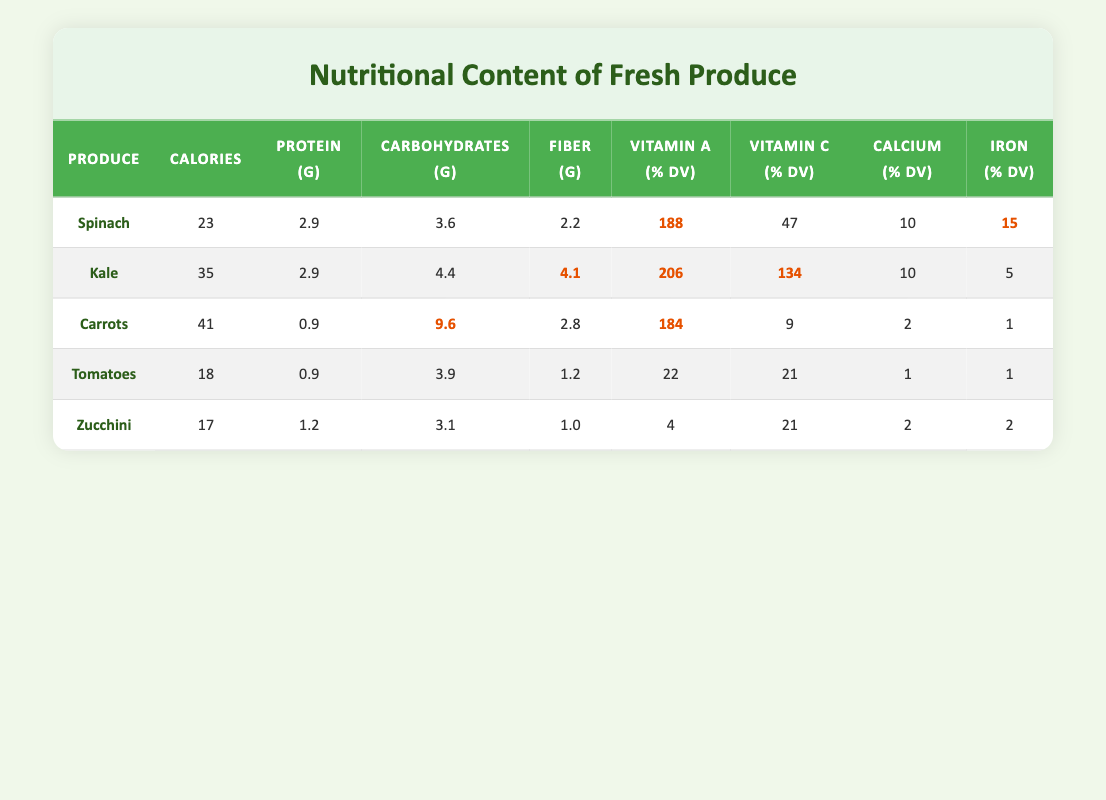What is the total protein content in spinach and kale combined? To find the total protein content, I will look at the protein values listed for spinach (2.9 g) and kale (2.9 g). Adding these together gives 2.9 + 2.9 = 5.8 g.
Answer: 5.8 g Which produce has the highest Vitamin C percentage? By examining the Vitamin C (% DV) column, kale has the highest value at 134%.
Answer: Kale Is the calcium content in carrots greater than that in tomatoes? Looking at the calcium (% DV) values, carrots have a value of 2%, while tomatoes have a value of 1%. Since 2% is greater than 1%, the statement is true.
Answer: Yes What is the average calorie content of all the produce listed? To calculate the average, I will sum the calories: 23 (spinach) + 35 (kale) + 41 (carrots) + 18 (tomatoes) + 17 (zucchini) = 134. Then, divide by the number of produce (5): 134 ÷ 5 = 26.8.
Answer: 26.8 Do any of these produce items provide 100% or more of the daily value of Vitamin A? Checking the Vitamin A (% DV) values, spinach (188%), kale (206%), and carrots (184%) all provide more than 100%. Thus, the statement is true.
Answer: Yes Which produce has the least amount of carbohydrates? Looking at the carbohydrates (g) column, zucchini has the lowest with 3.1 g compared to the others.
Answer: Zucchini What is the difference in calories between carrots and zucchini? I will find the calorie values for carrots (41) and zucchini (17). Subtracting gives 41 - 17 = 24 calories difference.
Answer: 24 calories Which produce item has the highest fiber content? By reviewing the fiber (g) column, kale shows the highest at 4.1 g.
Answer: Kale 